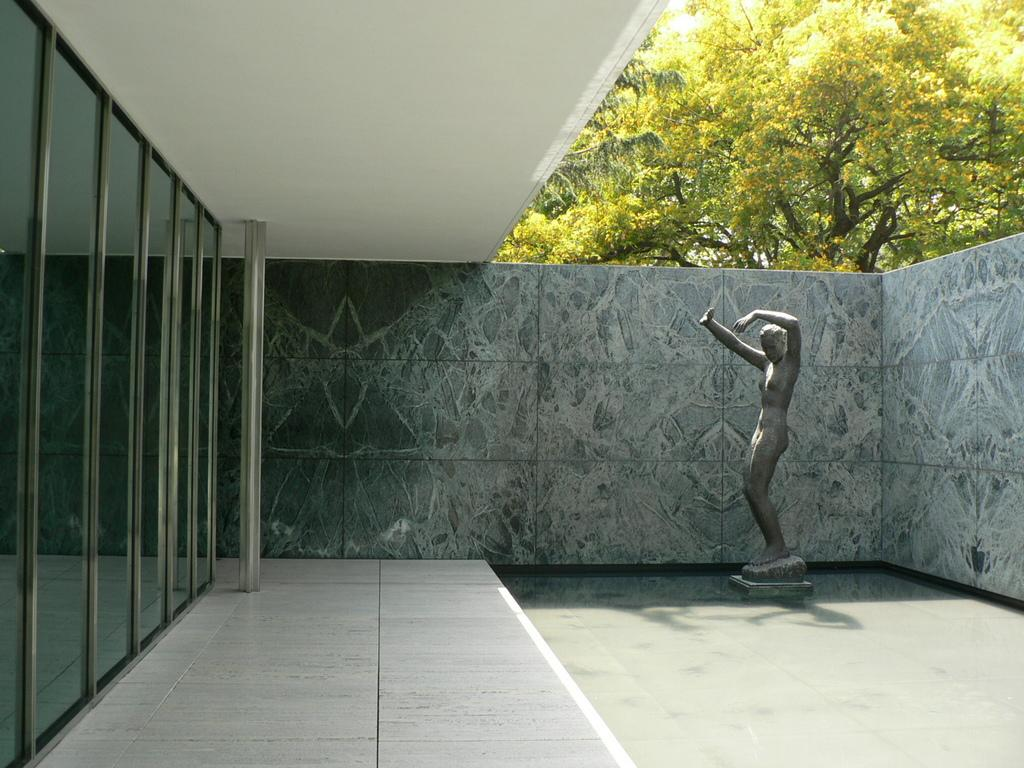What type of structures can be seen in the image? There are walls in the image. What natural elements are present in the image? There are trees in the image. What can be observed on the ground in the image? There is a shadow in the image. What type of artwork is visible in the image? There is a sculpture in the image. What type of oatmeal is being served in the image? There is no oatmeal present in the image. How can one place an order for the sculpture in the image? The image does not depict a situation where one can place an order for the sculpture, as it is a static representation of the artwork. 